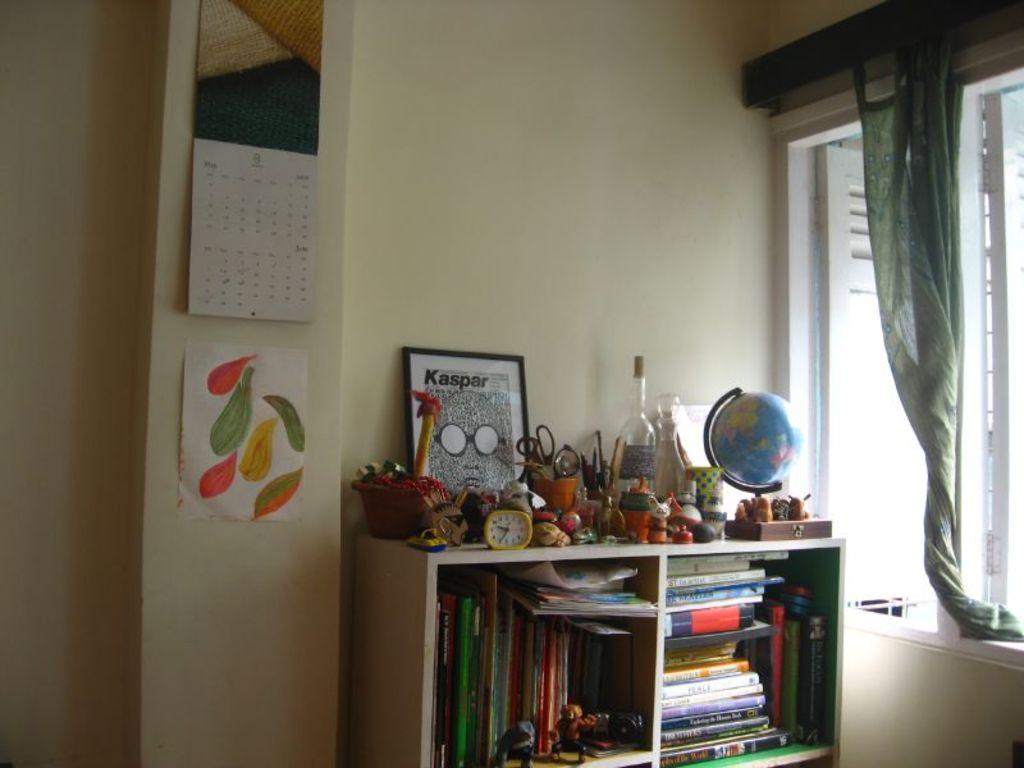What large name is on the framed picture on the shelf?
Make the answer very short. Kaspar. What month is on the bottom of the calendar?
Keep it short and to the point. June. 